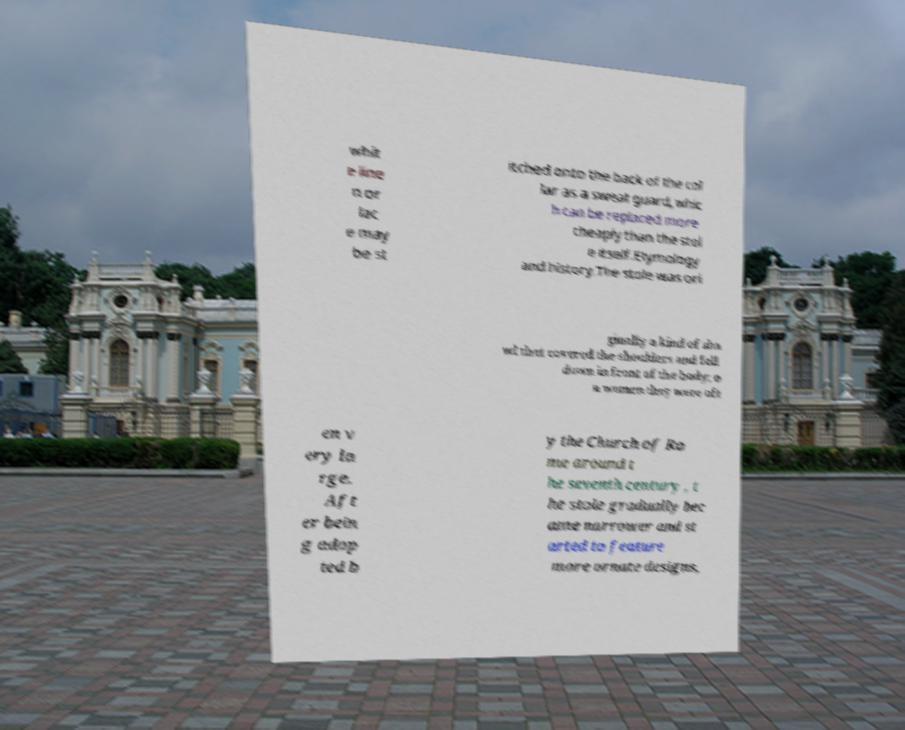For documentation purposes, I need the text within this image transcribed. Could you provide that? whit e line n or lac e may be st itched onto the back of the col lar as a sweat guard, whic h can be replaced more cheaply than the stol e itself.Etymology and history.The stole was ori ginally a kind of sha wl that covered the shoulders and fell down in front of the body; o n women they were oft en v ery la rge. Aft er bein g adop ted b y the Church of Ro me around t he seventh century , t he stole gradually bec ame narrower and st arted to feature more ornate designs, 